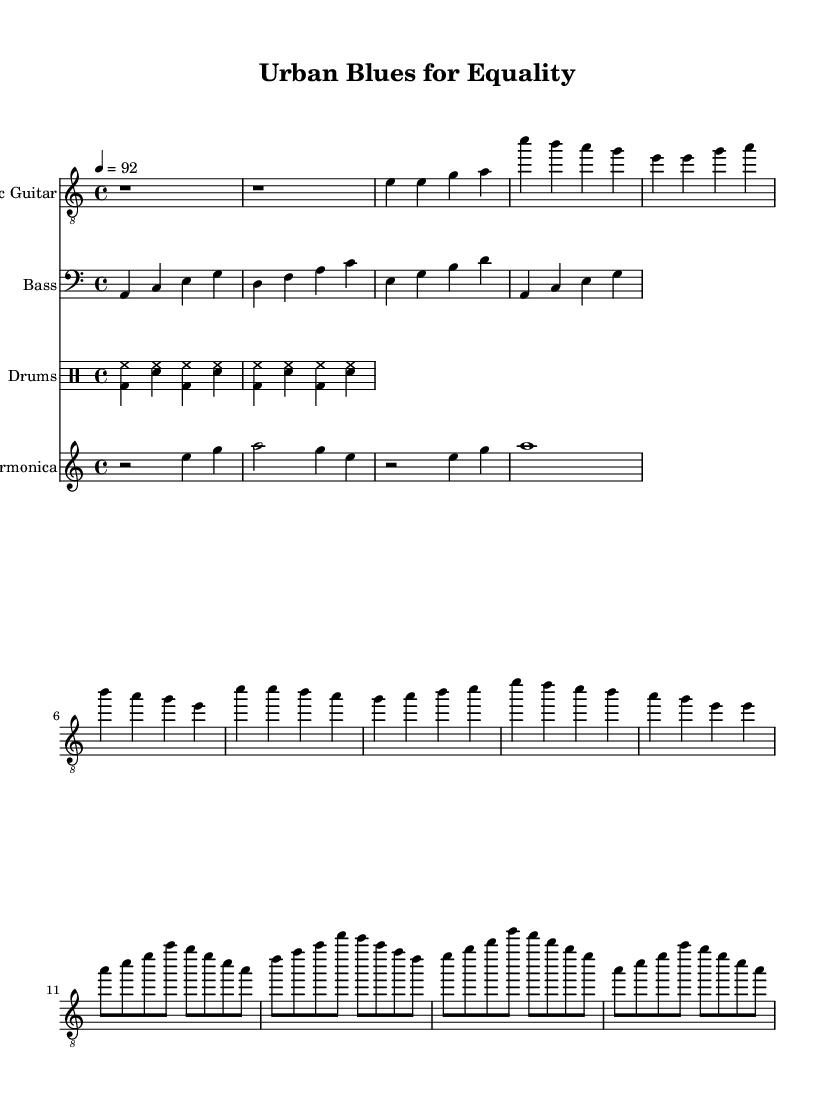What is the key signature of this music? The key signature is A minor, indicated by no sharps or flats, which typically suggests that the piece may have a somber or reflective mood.
Answer: A minor What is the time signature? The time signature is 4/4, which is shown at the beginning of the score. This means there are four beats in each measure and the quarter note receives one beat.
Answer: 4/4 What is the tempo marking? The tempo marking is 92 beats per minute, which is notated above the score. This indicates a moderate pace for the performance of the piece.
Answer: 92 How many sections are in the main structure of the piece? The main structure of the piece consists of an Intro, a Verse, a Chorus, and a Guitar Solo, totaling four distinct sections.
Answer: Four What type of rhythm is indicated in the drum part? The drum part indicates a basic blues shuffle pattern, characterized by a swing feel due to the combination of bass drum and hi-hat notations.
Answer: Blues shuffle What instruments are included in this score? The score includes Electric Guitar, Bass, Drums, and Harmonica, each specified by a separate staff in the score layout.
Answer: Electric Guitar, Bass, Drums, Harmonica What musical element is primarily featured in the harmonica part? The harmonica part primarily features melodic phrases and rests that create a call-and-response effect typical of blues music.
Answer: Melodic phrases 